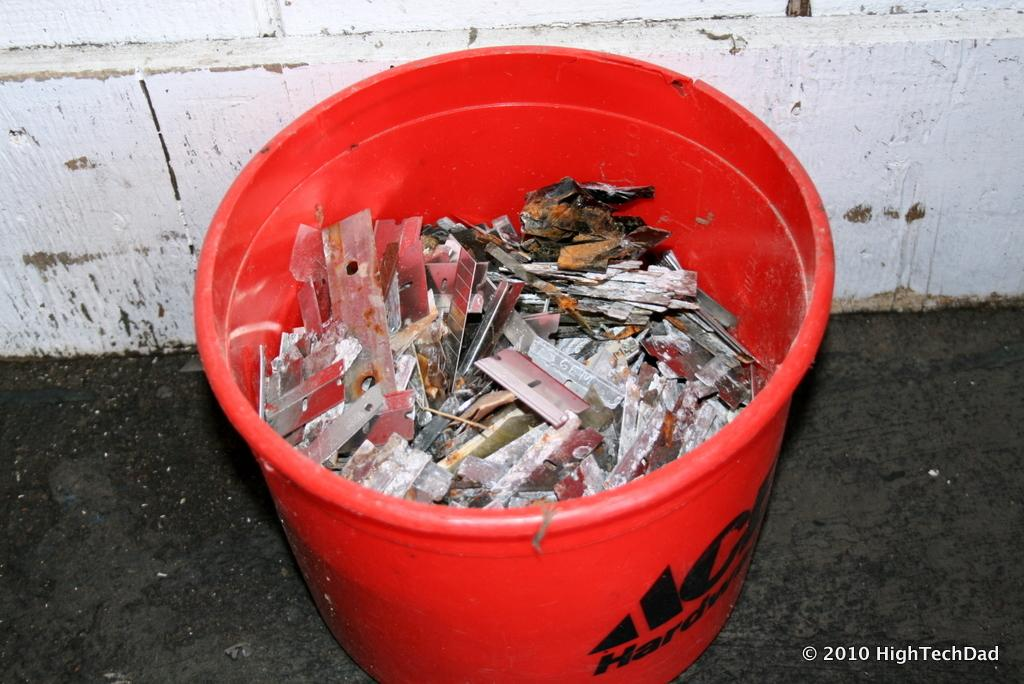<image>
Write a terse but informative summary of the picture. An ACE Hardware bucket is full of old razor blades. 